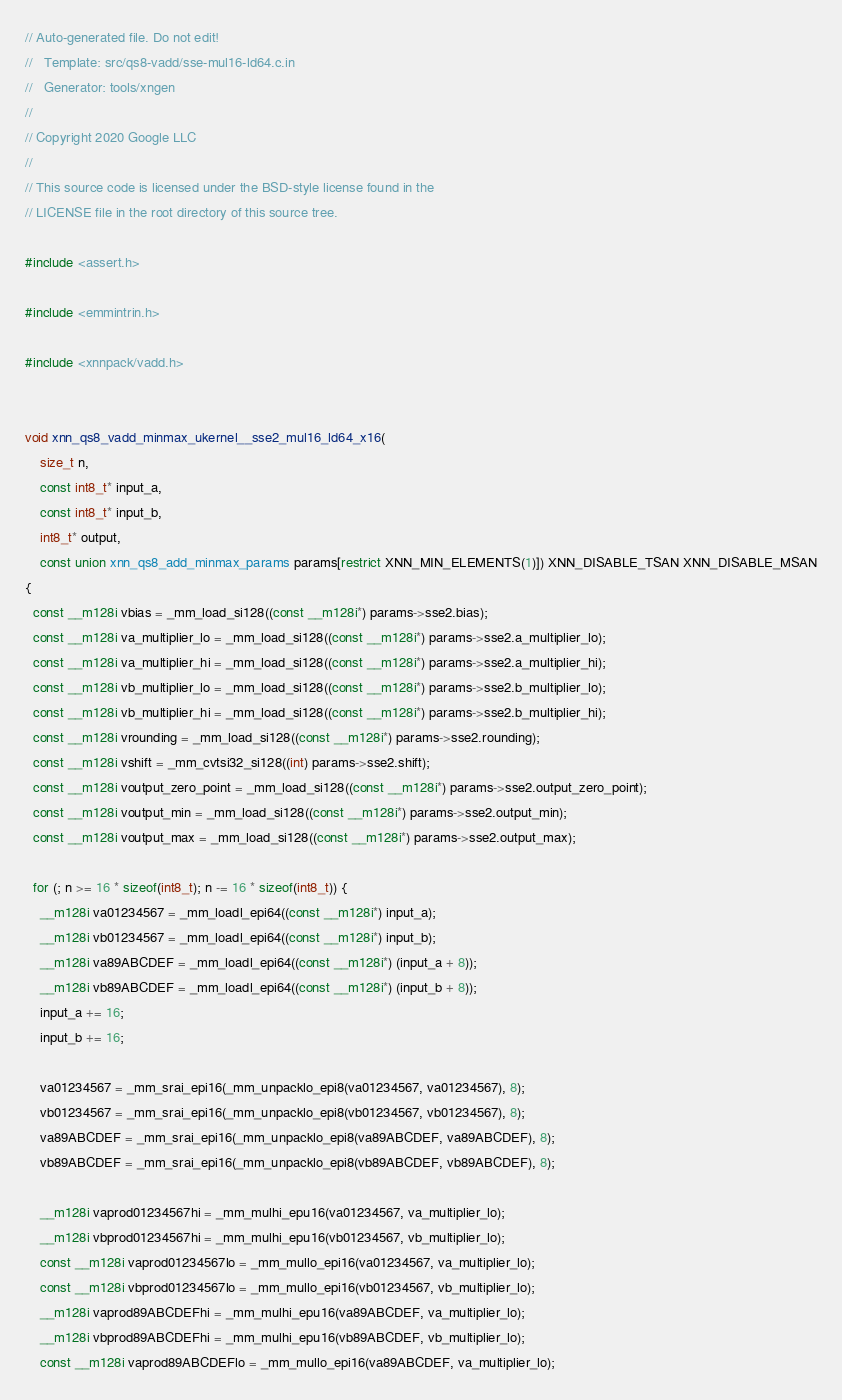Convert code to text. <code><loc_0><loc_0><loc_500><loc_500><_C_>// Auto-generated file. Do not edit!
//   Template: src/qs8-vadd/sse-mul16-ld64.c.in
//   Generator: tools/xngen
//
// Copyright 2020 Google LLC
//
// This source code is licensed under the BSD-style license found in the
// LICENSE file in the root directory of this source tree.

#include <assert.h>

#include <emmintrin.h>

#include <xnnpack/vadd.h>


void xnn_qs8_vadd_minmax_ukernel__sse2_mul16_ld64_x16(
    size_t n,
    const int8_t* input_a,
    const int8_t* input_b,
    int8_t* output,
    const union xnn_qs8_add_minmax_params params[restrict XNN_MIN_ELEMENTS(1)]) XNN_DISABLE_TSAN XNN_DISABLE_MSAN
{
  const __m128i vbias = _mm_load_si128((const __m128i*) params->sse2.bias);
  const __m128i va_multiplier_lo = _mm_load_si128((const __m128i*) params->sse2.a_multiplier_lo);
  const __m128i va_multiplier_hi = _mm_load_si128((const __m128i*) params->sse2.a_multiplier_hi);
  const __m128i vb_multiplier_lo = _mm_load_si128((const __m128i*) params->sse2.b_multiplier_lo);
  const __m128i vb_multiplier_hi = _mm_load_si128((const __m128i*) params->sse2.b_multiplier_hi);
  const __m128i vrounding = _mm_load_si128((const __m128i*) params->sse2.rounding);
  const __m128i vshift = _mm_cvtsi32_si128((int) params->sse2.shift);
  const __m128i voutput_zero_point = _mm_load_si128((const __m128i*) params->sse2.output_zero_point);
  const __m128i voutput_min = _mm_load_si128((const __m128i*) params->sse2.output_min);
  const __m128i voutput_max = _mm_load_si128((const __m128i*) params->sse2.output_max);

  for (; n >= 16 * sizeof(int8_t); n -= 16 * sizeof(int8_t)) {
    __m128i va01234567 = _mm_loadl_epi64((const __m128i*) input_a);
    __m128i vb01234567 = _mm_loadl_epi64((const __m128i*) input_b);
    __m128i va89ABCDEF = _mm_loadl_epi64((const __m128i*) (input_a + 8));
    __m128i vb89ABCDEF = _mm_loadl_epi64((const __m128i*) (input_b + 8));
    input_a += 16;
    input_b += 16;

    va01234567 = _mm_srai_epi16(_mm_unpacklo_epi8(va01234567, va01234567), 8);
    vb01234567 = _mm_srai_epi16(_mm_unpacklo_epi8(vb01234567, vb01234567), 8);
    va89ABCDEF = _mm_srai_epi16(_mm_unpacklo_epi8(va89ABCDEF, va89ABCDEF), 8);
    vb89ABCDEF = _mm_srai_epi16(_mm_unpacklo_epi8(vb89ABCDEF, vb89ABCDEF), 8);

    __m128i vaprod01234567hi = _mm_mulhi_epu16(va01234567, va_multiplier_lo);
    __m128i vbprod01234567hi = _mm_mulhi_epu16(vb01234567, vb_multiplier_lo);
    const __m128i vaprod01234567lo = _mm_mullo_epi16(va01234567, va_multiplier_lo);
    const __m128i vbprod01234567lo = _mm_mullo_epi16(vb01234567, vb_multiplier_lo);
    __m128i vaprod89ABCDEFhi = _mm_mulhi_epu16(va89ABCDEF, va_multiplier_lo);
    __m128i vbprod89ABCDEFhi = _mm_mulhi_epu16(vb89ABCDEF, vb_multiplier_lo);
    const __m128i vaprod89ABCDEFlo = _mm_mullo_epi16(va89ABCDEF, va_multiplier_lo);</code> 